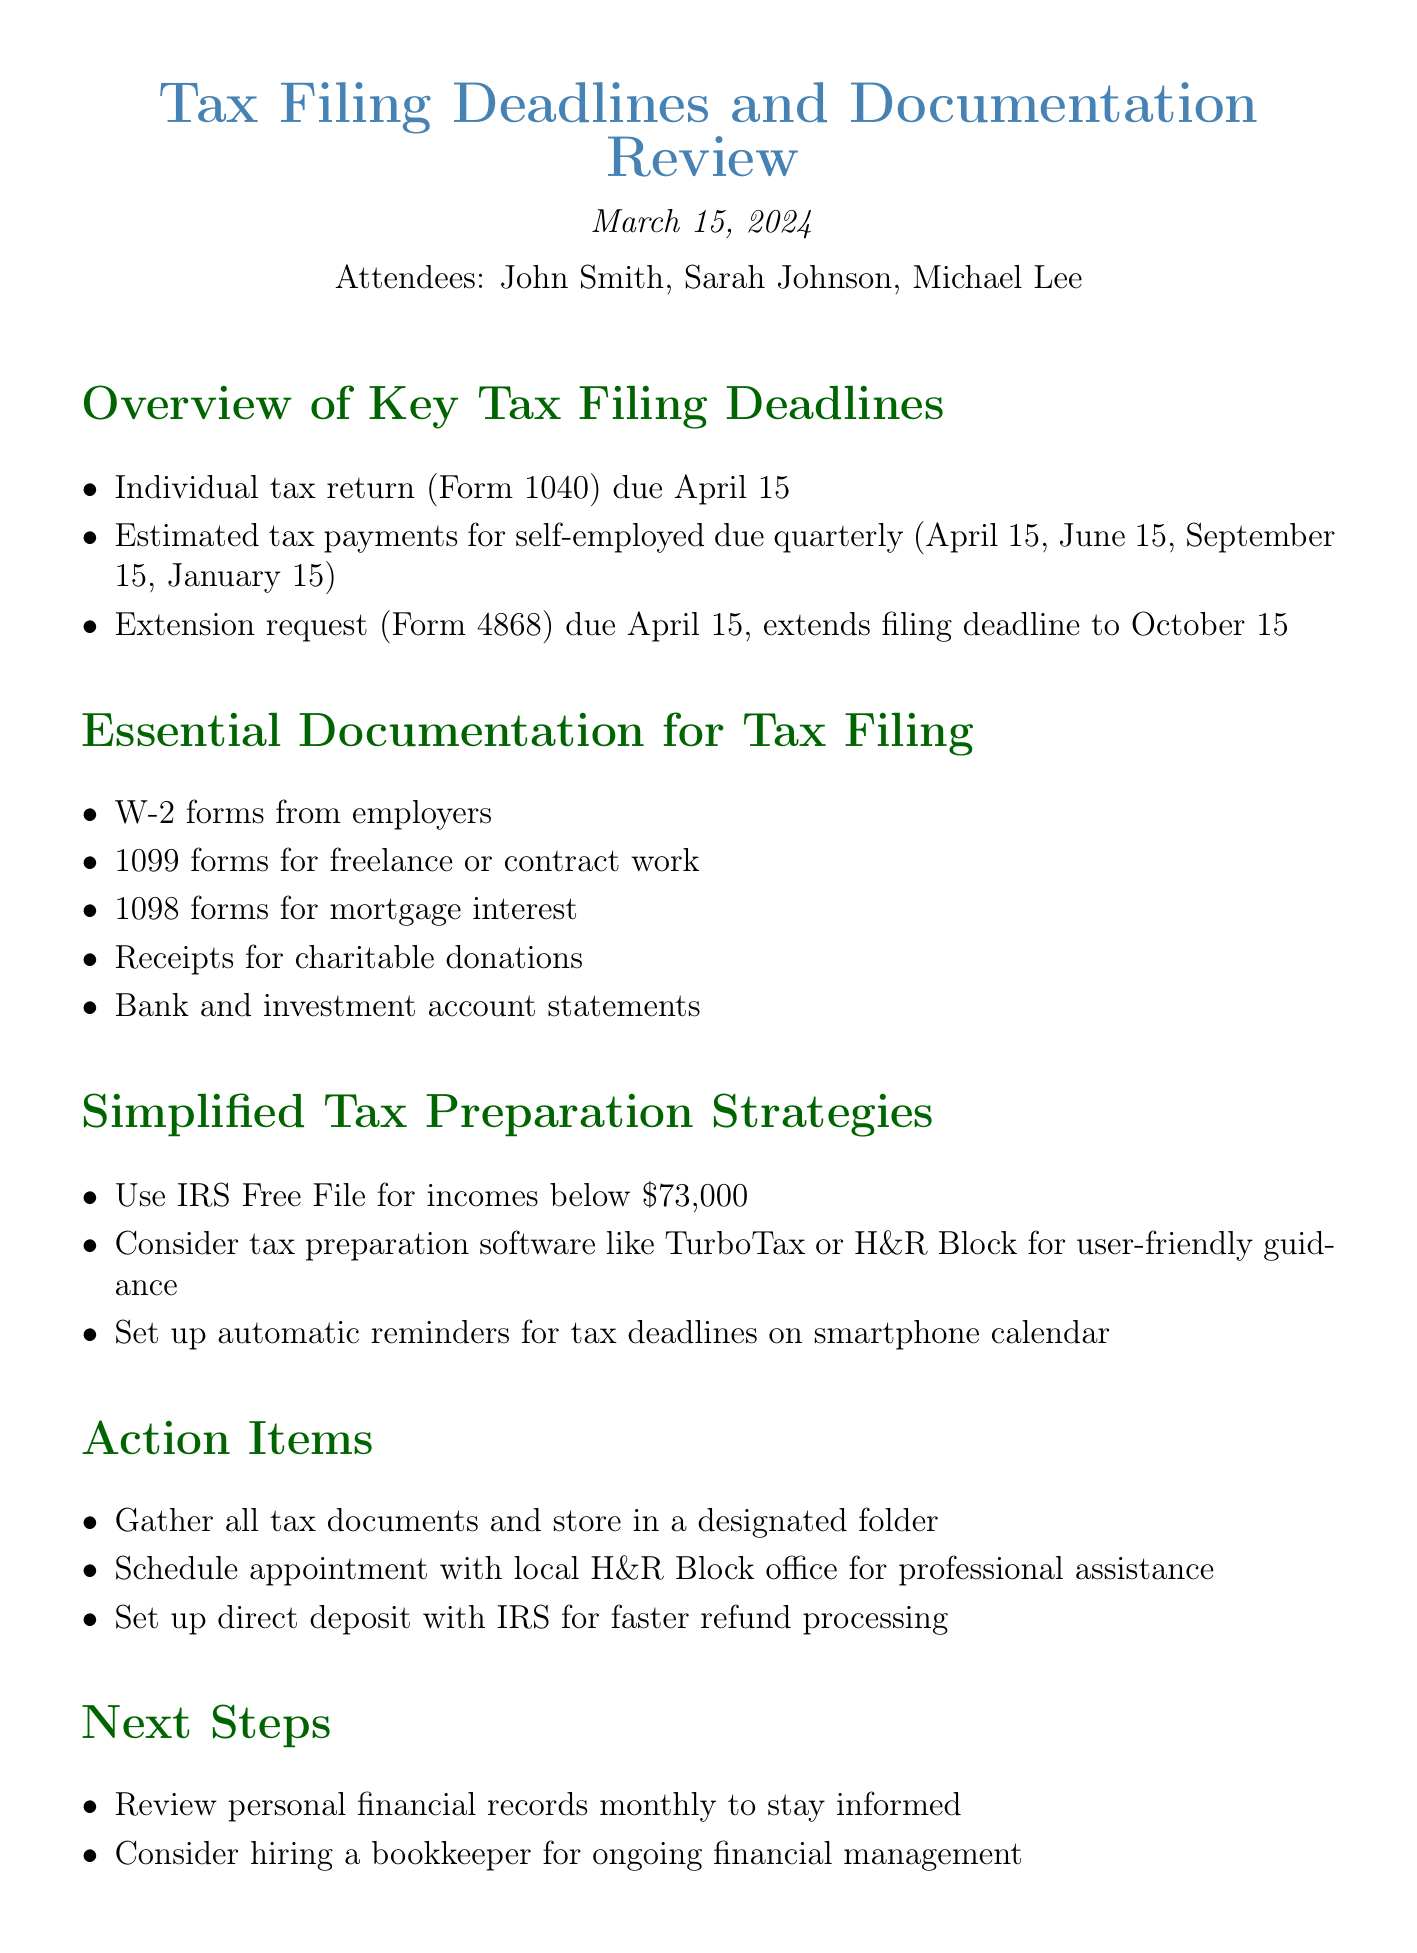What is the title of the meeting? The title of the meeting is stated at the beginning of the document.
Answer: Tax Filing Deadlines and Documentation Review When is the individual tax return due? The due date for the individual tax return is mentioned under key deadlines.
Answer: April 15 What forms do you need from your employers? The essential documentation includes specific forms listed.
Answer: W-2 forms How often are estimated tax payments due for the self-employed? The document outlines the frequency of estimated tax payments.
Answer: Quarterly What is the purpose of Form 4868? The document briefly describes the function of this form related to tax deadlines.
Answer: Extension request What is a suggested strategy for tax preparation? The document includes strategies that can help with tax preparation.
Answer: Use IRS Free File for incomes below $73,000 What is an action item regarding tax documents? One of the action items focuses on organizing tax documents.
Answer: Gather all tax documents and store in a designated folder What is one next step suggested after the meeting? The next steps outline actions that can help in managing finances post-meeting.
Answer: Review personal financial records monthly to stay informed 